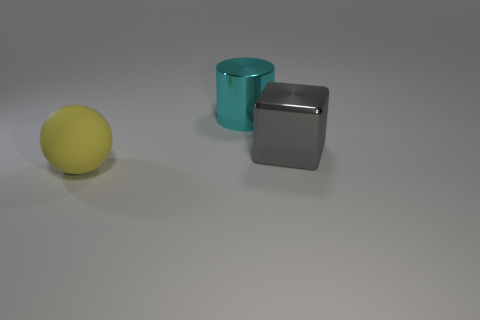Add 1 cyan matte spheres. How many objects exist? 4 Subtract all balls. How many objects are left? 2 Add 3 big balls. How many big balls are left? 4 Add 3 balls. How many balls exist? 4 Subtract 0 blue blocks. How many objects are left? 3 Subtract all gray objects. Subtract all yellow objects. How many objects are left? 1 